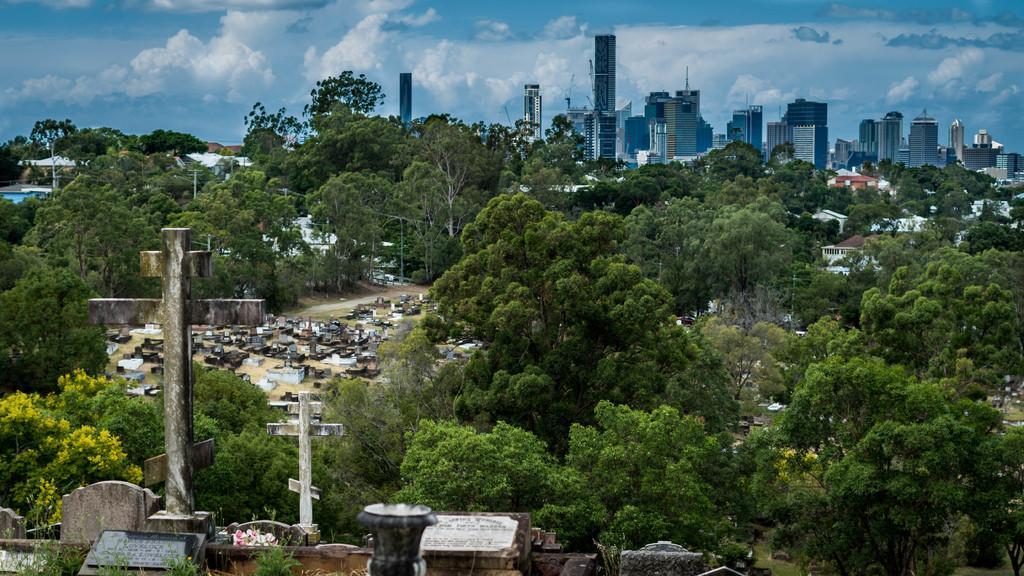In one or two sentences, can you explain what this image depicts? In this image, we can see so many trees, houses, buildings, poles, plants, grass, some objects. Top of the image, there is a cloudy sky. 